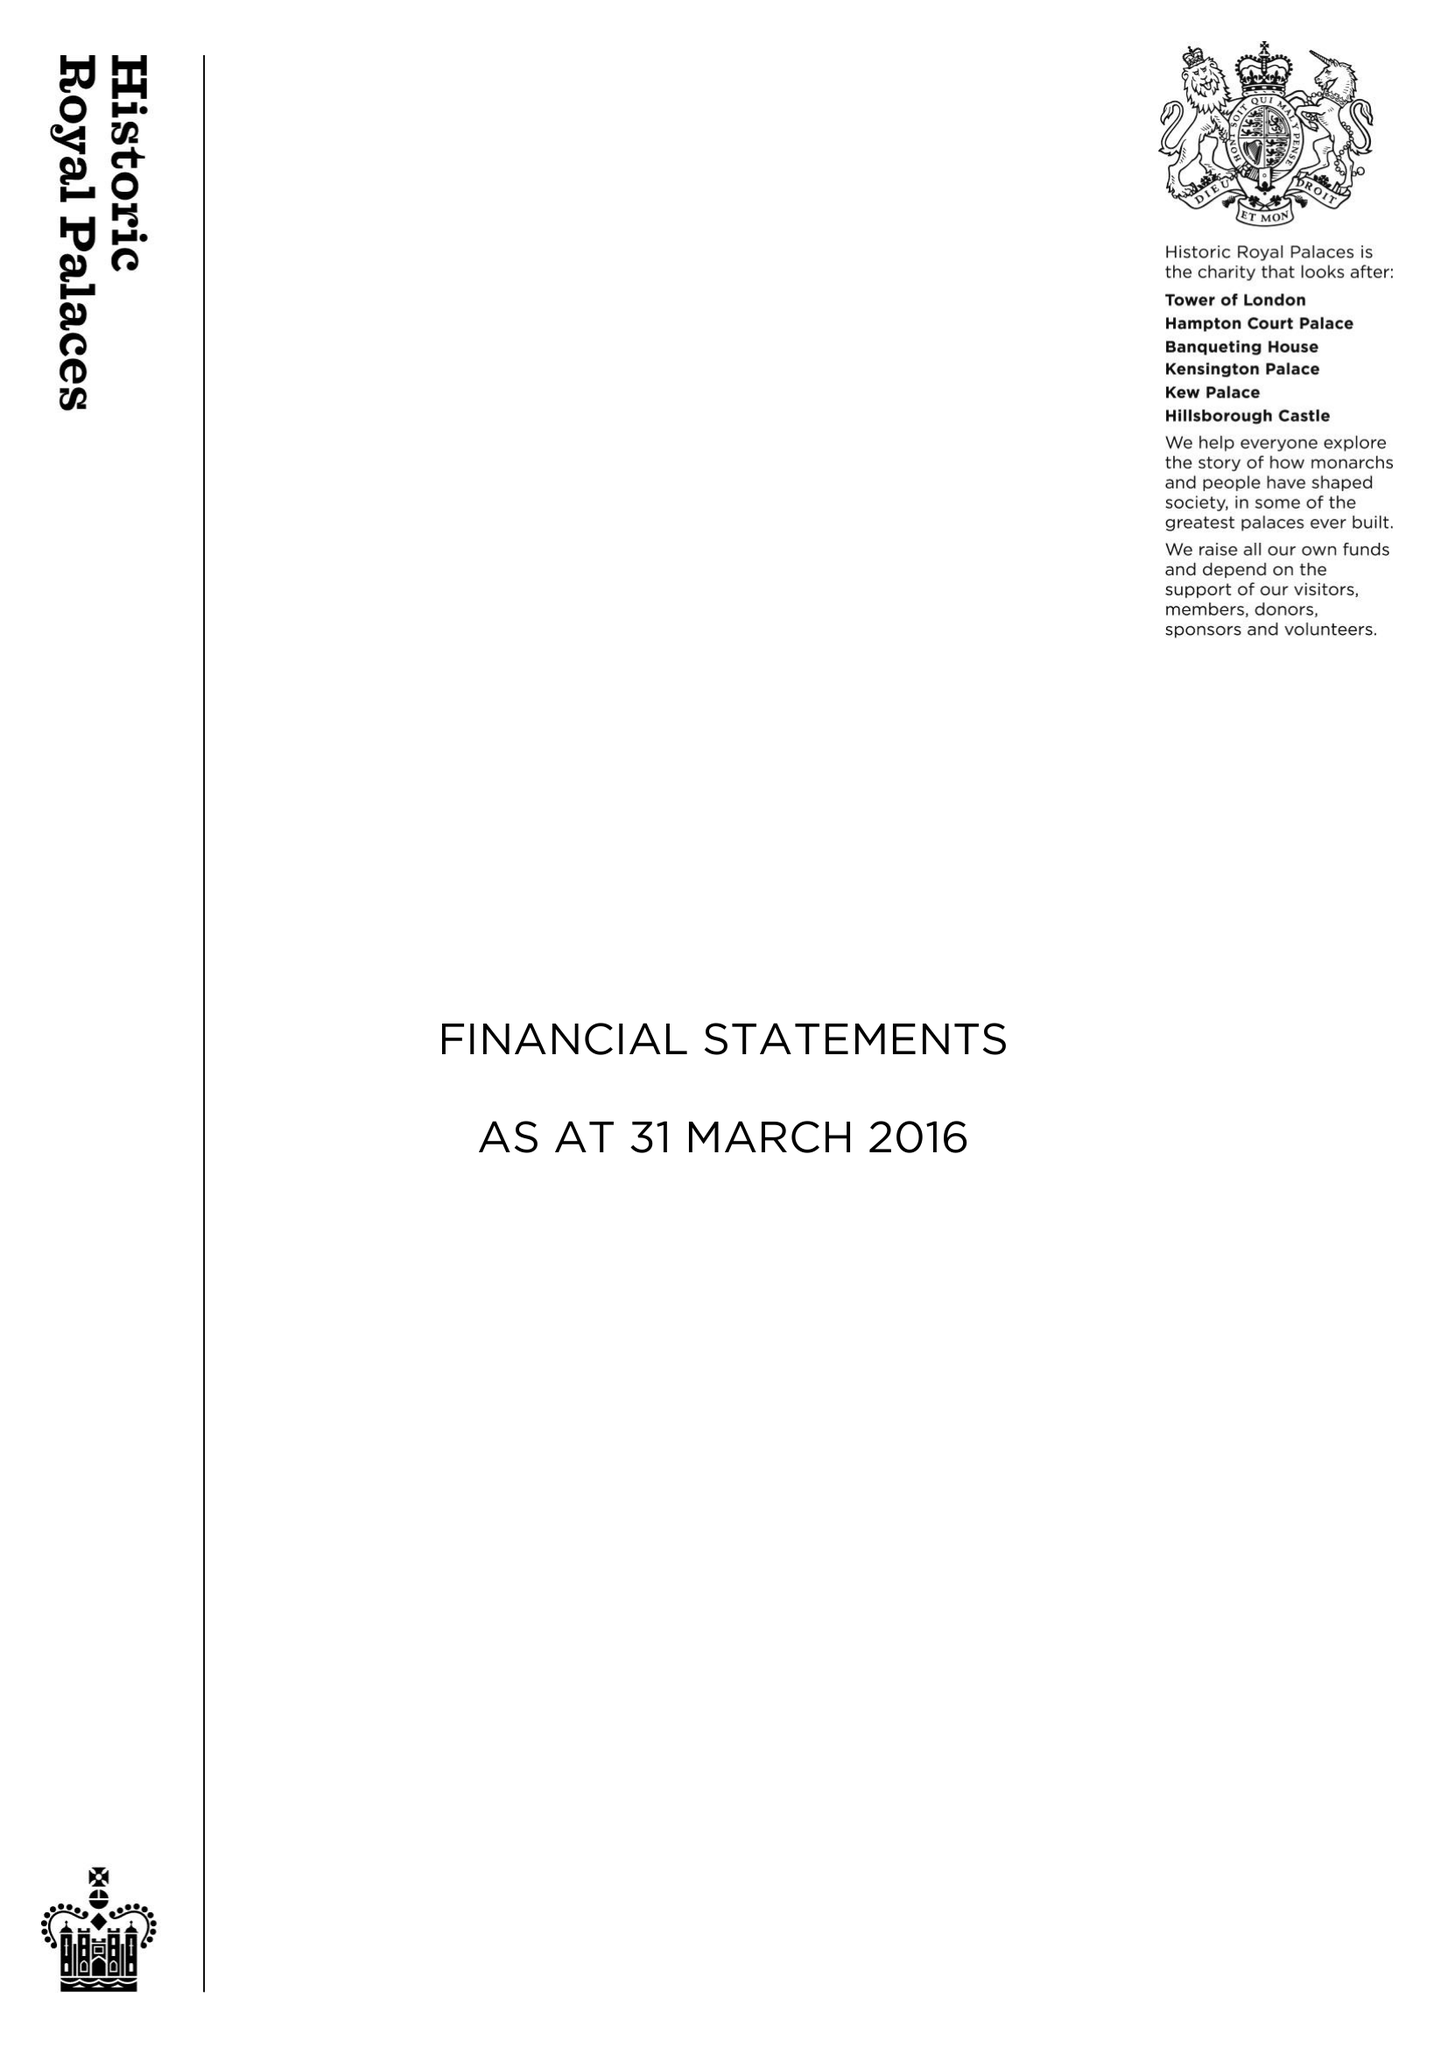What is the value for the address__post_town?
Answer the question using a single word or phrase. WEST MOLESEY 